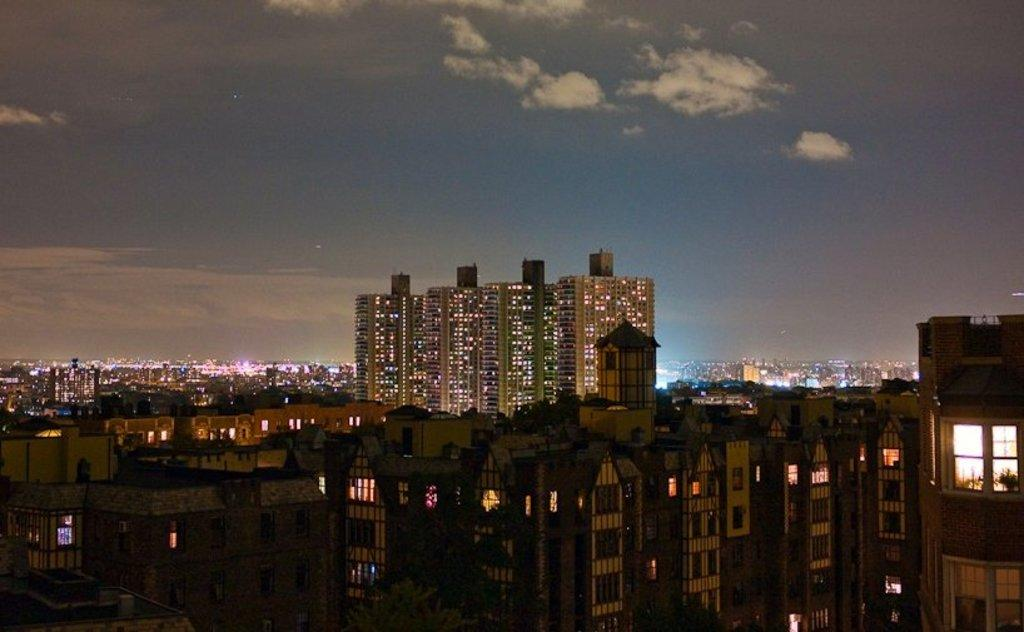What structures are located in the foreground of the image? There are buildings in the foreground of the image. What can be seen in the background of the image? The background of the image includes the city. What is visible in the sky in the image? The sky is visible in the image, and clouds are present. What type of suit is the texture of the clouds in the image? The clouds in the image do not have a texture like a suit; they are a natural atmospheric phenomenon. What is the cause of the clouds in the image? The cause of the clouds in the image is the natural process of water vapor condensing in the atmosphere. 